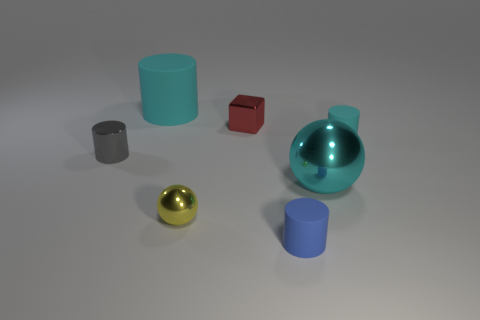Is there any other thing that has the same shape as the tiny red metallic thing?
Ensure brevity in your answer.  No. There is another blue cylinder that is the same size as the metallic cylinder; what is its material?
Provide a succinct answer. Rubber. There is a small thing to the left of the cyan cylinder to the left of the tiny blue cylinder; what is it made of?
Offer a terse response. Metal. There is a metallic object behind the gray metal cylinder; does it have the same shape as the small blue matte object?
Your answer should be very brief. No. What is the color of the large sphere that is made of the same material as the tiny cube?
Give a very brief answer. Cyan. There is a small cylinder in front of the metal cylinder; what is it made of?
Your answer should be compact. Rubber. There is a tiny cyan thing; does it have the same shape as the big cyan thing on the left side of the small yellow shiny thing?
Give a very brief answer. Yes. What is the small thing that is on the left side of the small blue cylinder and on the right side of the tiny yellow sphere made of?
Provide a succinct answer. Metal. The thing that is the same size as the cyan ball is what color?
Make the answer very short. Cyan. Are the blue cylinder and the object behind the small cube made of the same material?
Make the answer very short. Yes. 